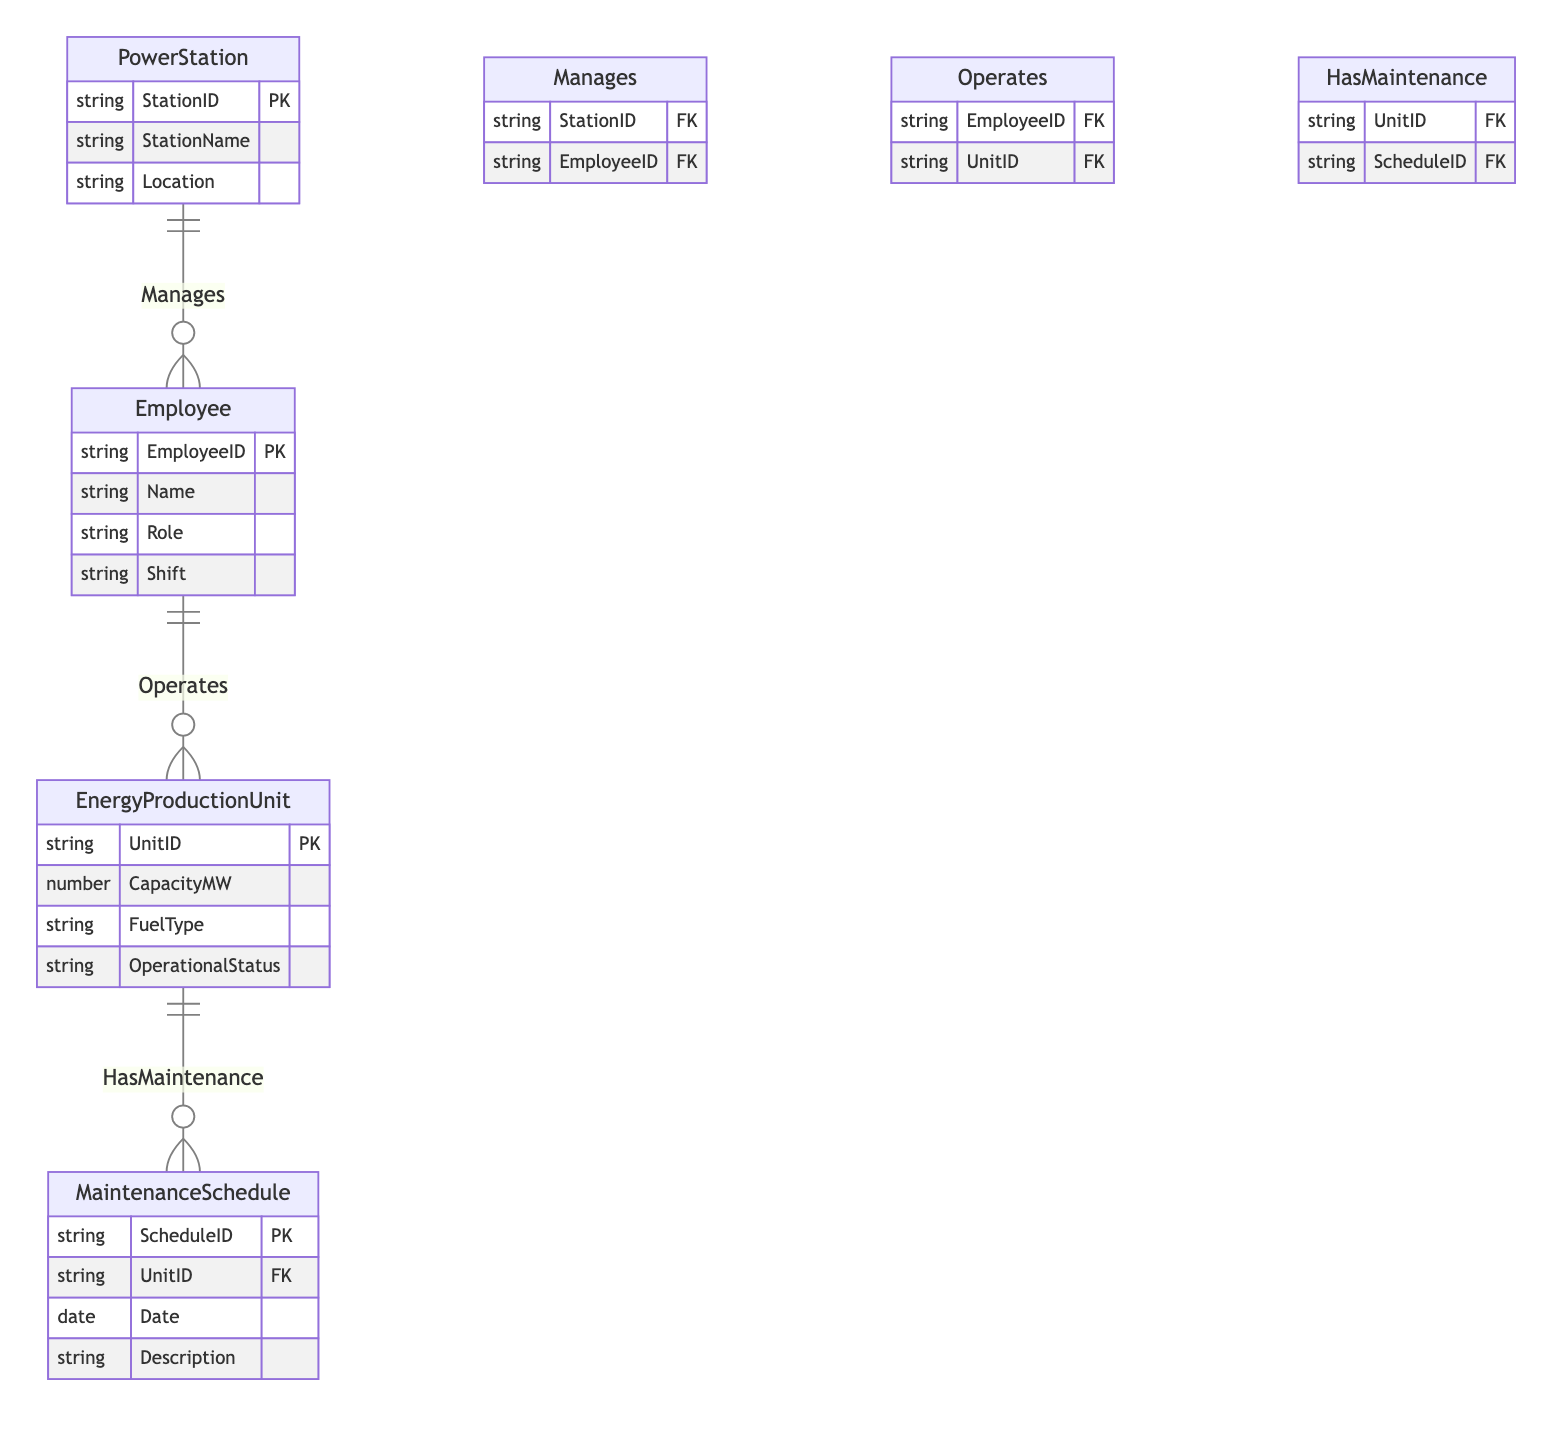What entities are involved in the energy production process? The entities involved are PowerStation, EnergyProductionUnit, Employee, and MaintenanceSchedule. These entities represent key components in the energy production framework.
Answer: PowerStation, EnergyProductionUnit, Employee, MaintenanceSchedule How many attributes does the Employee entity have? The Employee entity has four attributes: EmployeeID, Name, Role, and Shift, which provides essential information about each employee.
Answer: Four What is the primary key of the EnergyProductionUnit? The primary key of the EnergyProductionUnit is UnitID, which uniquely identifies each energy production unit in the system.
Answer: UnitID Which entity manages employees at a power station? The PowerStation entity manages employees as indicated by the "Manages" relationship connecting PowerStation and Employee.
Answer: PowerStation What relationship exists between Employee and EnergyProductionUnit? The relationship is called "Operates," indicating that employees operate energy production units as part of their roles.
Answer: Operates How many foreign keys are in the MaintenanceSchedule entity? The MaintenanceSchedule entity has one foreign key: UnitID, which links the maintenance schedule back to a specific energy production unit.
Answer: One Which entity has a relationship with MaintenanceSchedule that involves UnitID? The EnergyProductionUnit entity has a relationship with MaintenanceSchedule that involves the foreign key UnitID, indicating which unit is undergoing maintenance.
Answer: EnergyProductionUnit What is the role of the Employee in the context of the Operates relationship? In the context of the Operates relationship, the role of the Employee is to operate the EnergyProductionUnit, showcasing their direct involvement in energy production activities.
Answer: Operate What type of fuel can be used in EnergyProductionUnit? The fuel type is specified as an attribute of EnergyProductionUnit, allowing for a diverse range of energy sources depending on the operational requirements.
Answer: FuelType 